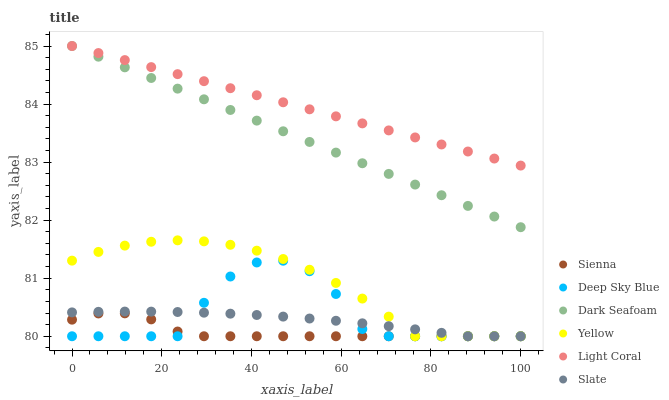Does Sienna have the minimum area under the curve?
Answer yes or no. Yes. Does Light Coral have the maximum area under the curve?
Answer yes or no. Yes. Does Slate have the minimum area under the curve?
Answer yes or no. No. Does Slate have the maximum area under the curve?
Answer yes or no. No. Is Light Coral the smoothest?
Answer yes or no. Yes. Is Deep Sky Blue the roughest?
Answer yes or no. Yes. Is Slate the smoothest?
Answer yes or no. No. Is Slate the roughest?
Answer yes or no. No. Does Slate have the lowest value?
Answer yes or no. Yes. Does Dark Seafoam have the lowest value?
Answer yes or no. No. Does Dark Seafoam have the highest value?
Answer yes or no. Yes. Does Slate have the highest value?
Answer yes or no. No. Is Yellow less than Light Coral?
Answer yes or no. Yes. Is Dark Seafoam greater than Deep Sky Blue?
Answer yes or no. Yes. Does Deep Sky Blue intersect Sienna?
Answer yes or no. Yes. Is Deep Sky Blue less than Sienna?
Answer yes or no. No. Is Deep Sky Blue greater than Sienna?
Answer yes or no. No. Does Yellow intersect Light Coral?
Answer yes or no. No. 